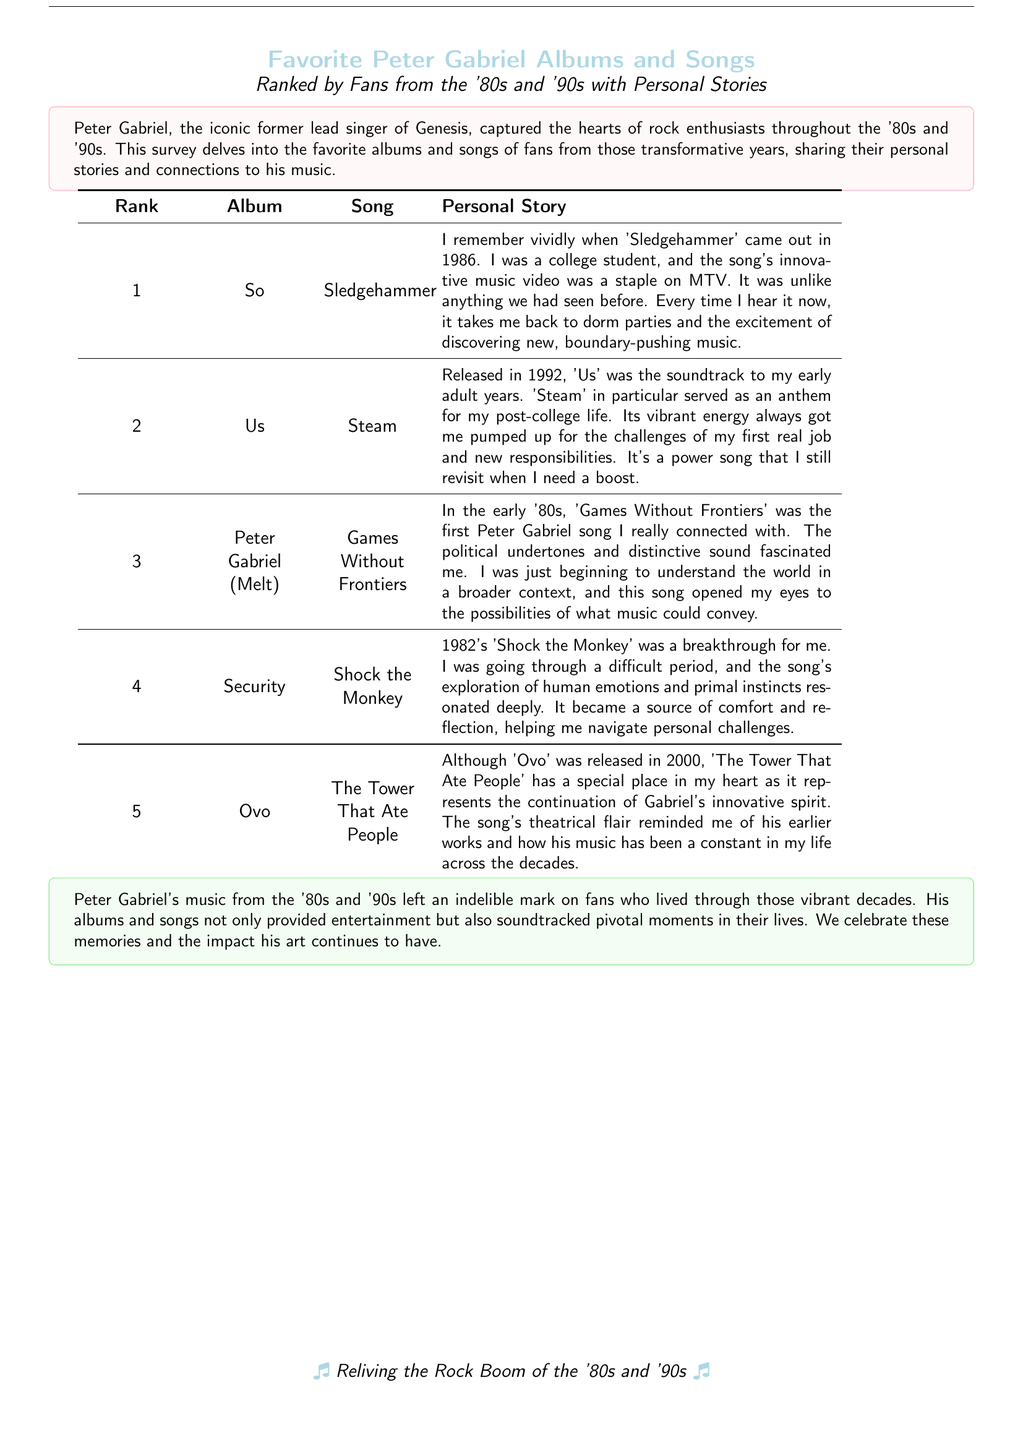What is the highest-ranked album? The highest-ranked album is listed as number 1 in the table.
Answer: So Which song is ranked second? The song in the second rank is specified in the table under the corresponding album.
Answer: Steam How many personal stories are shared? The document contains a total of five entries, each with a personal story associated with an album and song.
Answer: 5 What year was 'Sledgehammer' released? The release year of 'Sledgehammer' is mentioned within its personal story context.
Answer: 1986 Which album features the song 'Games Without Frontiers'? The album connected to that song can be found in the album column next to the song itself.
Answer: Peter Gabriel (Melt) What emotion does 'Shock the Monkey' explore, according to the personal story? The emotional theme of the song is summarized in the personal story reflecting on its relevance.
Answer: Human emotions What year was the album 'Us' released? The year 'Us' is noted in relation to its featured song in the document.
Answer: 1992 Which song represents the continuation of Gabriel's innovative spirit? This song's relevance is discussed in the personal story in connection with Gabriel's career.
Answer: The Tower That Ate People What is the document's primary theme? The overarching theme of the document is summarized in the introductory tcolorbox.
Answer: Favorite albums and songs 